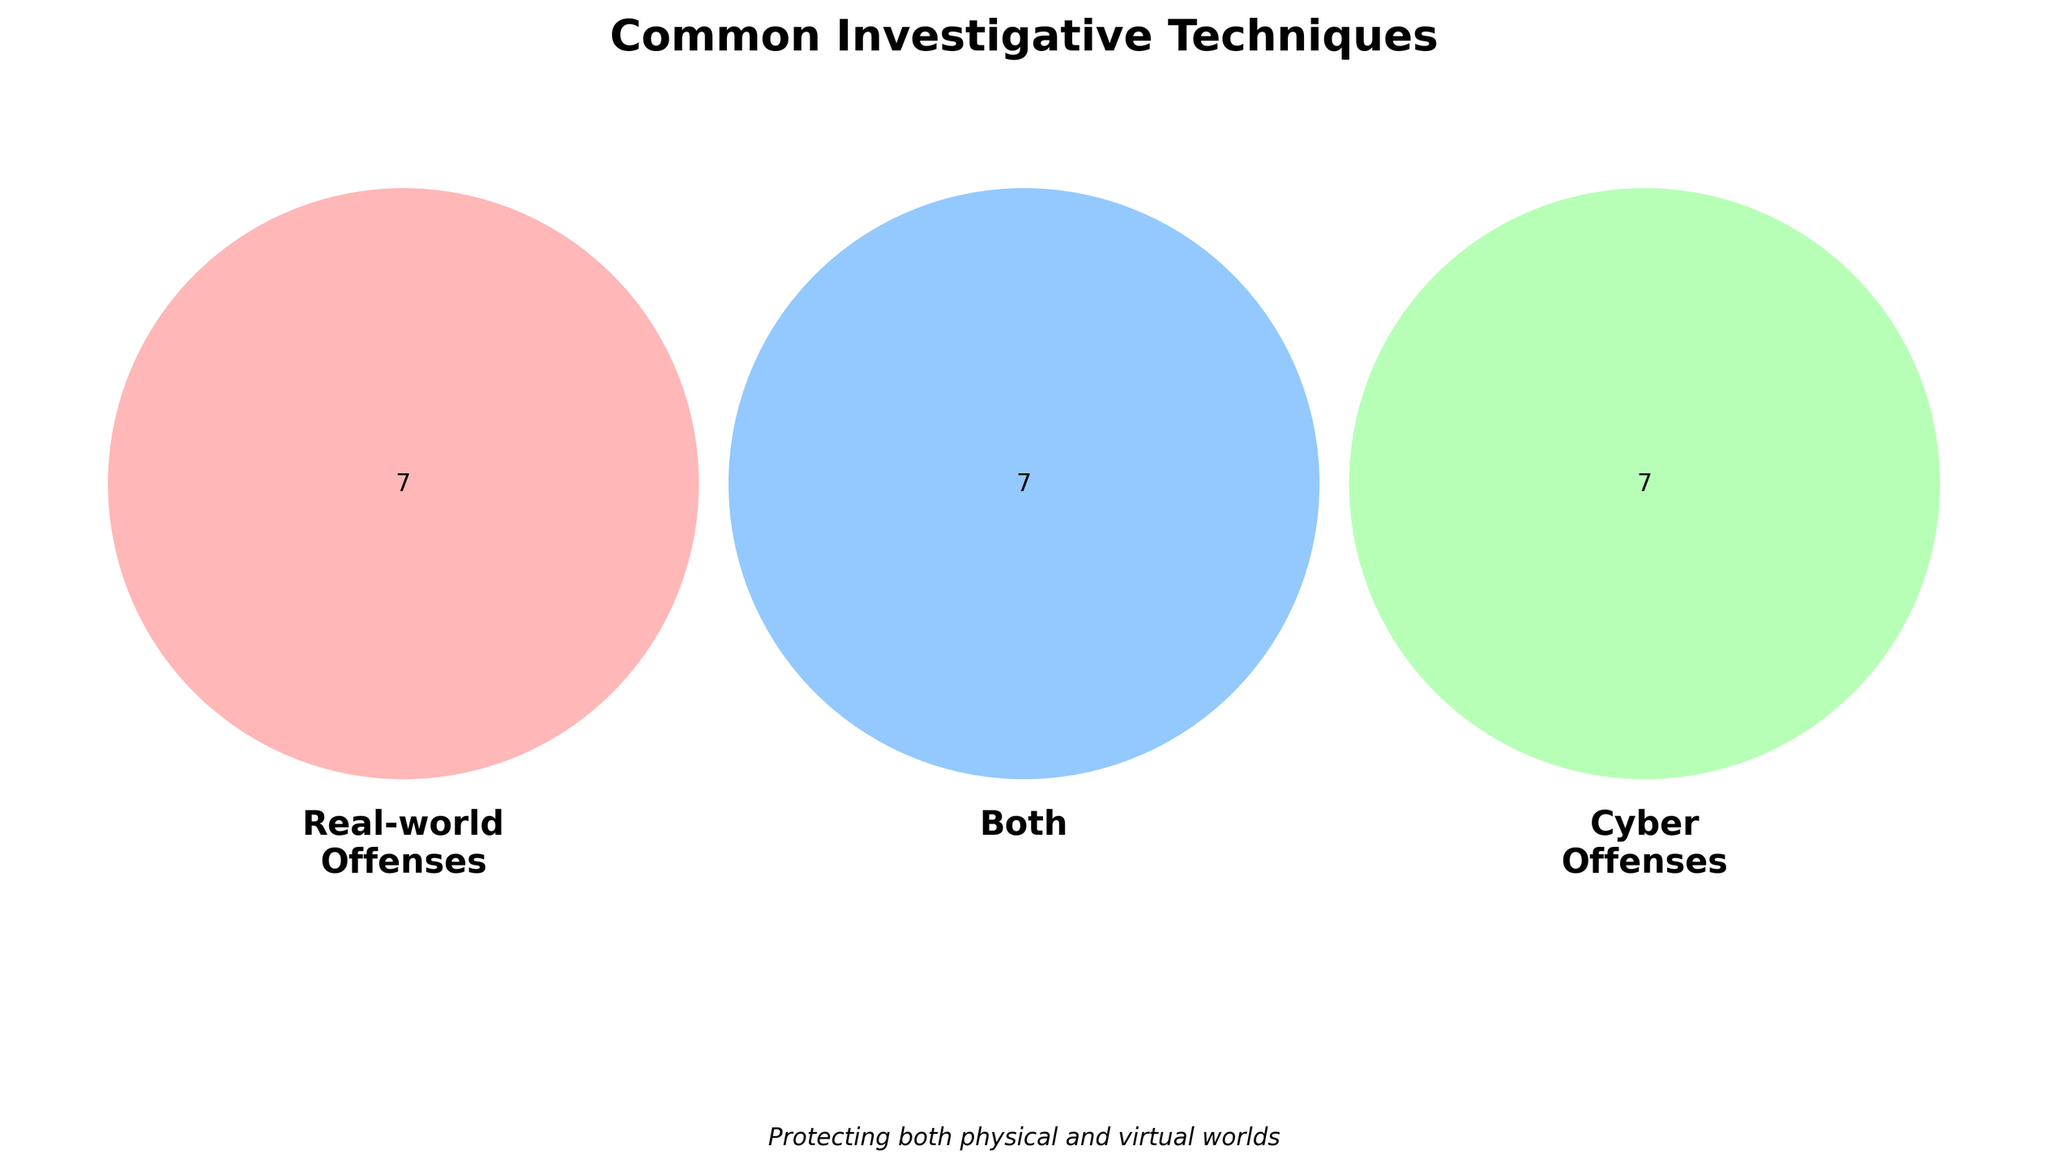What are two investigative techniques unique to real-world offenses? From the Venn Diagram, look at the section labeled "Real-world Offenses" which does not intersect with any other sections. Identify two techniques listed there.
Answer: Witness interviews, Ballistics testing What methods are common to both real-world and cyber offenses? Examine the central section of the Venn Diagram where all circles intersect, representing techniques shared by both real-world and cyber offenses. List them out.
Answer: Surveillance, Data recovery How many unique investigative techniques are used in cyber offenses only? Count the number of techniques listed in the "Cyber Offenses" section that does not overlap with any other sections.
Answer: 6 Are there more techniques exclusive to cyber offenses than real-world offenses? Compare the count of exclusive techniques in the "Cyber Offenses" section with that in the "Real-world Offenses" section.
Answer: Yes Which section has 'Timeline reconstruction'? Identify the section of the Venn Diagram where 'Timeline reconstruction' is listed, which should be in both real-world and cyber offenses.
Answer: Both What is a common investigative technique used to track suspects in both real-world and cyber offenses? Look for a technique in the intersection area of real-world and cyber offenses related to tracking suspects.
Answer: Behavioral profiling What real-world technique relates to physical evidence but is not used in cyber offenses? Search the "Real-world Offenses" section for techniques related to physical evidence not shared with cyber offenses.
Answer: Fingerprint analysis Which technique unique to cyber offenses could help understand network activities? Identify a technique specific to the "Cyber Offenses" section related to network activity analysis.
Answer: Network traffic analysis How many investigative techniques are shared between real-world, both, and cyber offenses collectively? Count all techniques listed in the Venn Diagram, considering each section (Real-world Offenses, Both, Cyber Offenses).
Answer: 24 techniques 